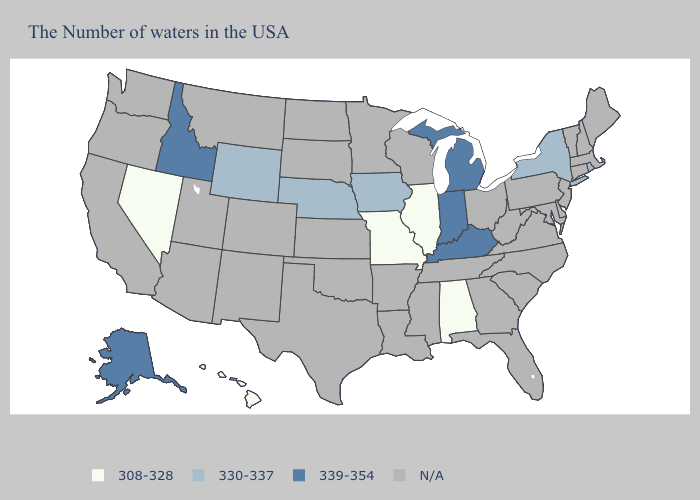Does the map have missing data?
Keep it brief. Yes. Does Nebraska have the highest value in the USA?
Concise answer only. No. Which states have the lowest value in the USA?
Short answer required. Alabama, Illinois, Missouri, Nevada, Hawaii. What is the lowest value in the West?
Short answer required. 308-328. Name the states that have a value in the range 308-328?
Keep it brief. Alabama, Illinois, Missouri, Nevada, Hawaii. What is the value of Connecticut?
Be succinct. N/A. What is the value of Connecticut?
Keep it brief. N/A. Does the map have missing data?
Be succinct. Yes. Does Alabama have the highest value in the South?
Quick response, please. No. 